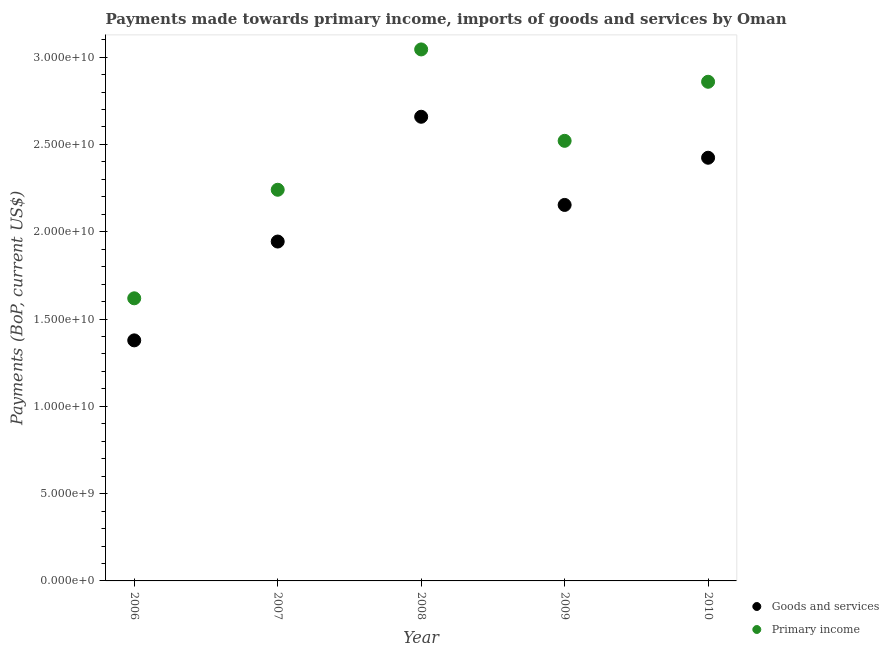Is the number of dotlines equal to the number of legend labels?
Provide a short and direct response. Yes. What is the payments made towards goods and services in 2006?
Keep it short and to the point. 1.38e+1. Across all years, what is the maximum payments made towards goods and services?
Make the answer very short. 2.66e+1. Across all years, what is the minimum payments made towards goods and services?
Your answer should be compact. 1.38e+1. What is the total payments made towards primary income in the graph?
Make the answer very short. 1.23e+11. What is the difference between the payments made towards goods and services in 2006 and that in 2009?
Ensure brevity in your answer.  -7.76e+09. What is the difference between the payments made towards primary income in 2010 and the payments made towards goods and services in 2006?
Your answer should be very brief. 1.48e+1. What is the average payments made towards primary income per year?
Your answer should be very brief. 2.46e+1. In the year 2006, what is the difference between the payments made towards primary income and payments made towards goods and services?
Your answer should be compact. 2.41e+09. In how many years, is the payments made towards goods and services greater than 19000000000 US$?
Your response must be concise. 4. What is the ratio of the payments made towards goods and services in 2008 to that in 2010?
Keep it short and to the point. 1.1. What is the difference between the highest and the second highest payments made towards goods and services?
Give a very brief answer. 2.35e+09. What is the difference between the highest and the lowest payments made towards goods and services?
Your response must be concise. 1.28e+1. In how many years, is the payments made towards primary income greater than the average payments made towards primary income taken over all years?
Offer a very short reply. 3. Does the payments made towards goods and services monotonically increase over the years?
Make the answer very short. No. How many dotlines are there?
Your answer should be compact. 2. How many years are there in the graph?
Offer a terse response. 5. Are the values on the major ticks of Y-axis written in scientific E-notation?
Ensure brevity in your answer.  Yes. Does the graph contain grids?
Make the answer very short. No. Where does the legend appear in the graph?
Give a very brief answer. Bottom right. How many legend labels are there?
Make the answer very short. 2. How are the legend labels stacked?
Provide a succinct answer. Vertical. What is the title of the graph?
Your response must be concise. Payments made towards primary income, imports of goods and services by Oman. Does "Net savings(excluding particulate emission damage)" appear as one of the legend labels in the graph?
Offer a very short reply. No. What is the label or title of the X-axis?
Offer a very short reply. Year. What is the label or title of the Y-axis?
Provide a succinct answer. Payments (BoP, current US$). What is the Payments (BoP, current US$) in Goods and services in 2006?
Your response must be concise. 1.38e+1. What is the Payments (BoP, current US$) in Primary income in 2006?
Make the answer very short. 1.62e+1. What is the Payments (BoP, current US$) of Goods and services in 2007?
Ensure brevity in your answer.  1.94e+1. What is the Payments (BoP, current US$) of Primary income in 2007?
Ensure brevity in your answer.  2.24e+1. What is the Payments (BoP, current US$) in Goods and services in 2008?
Keep it short and to the point. 2.66e+1. What is the Payments (BoP, current US$) of Primary income in 2008?
Provide a short and direct response. 3.04e+1. What is the Payments (BoP, current US$) in Goods and services in 2009?
Ensure brevity in your answer.  2.15e+1. What is the Payments (BoP, current US$) in Primary income in 2009?
Ensure brevity in your answer.  2.52e+1. What is the Payments (BoP, current US$) in Goods and services in 2010?
Offer a terse response. 2.42e+1. What is the Payments (BoP, current US$) of Primary income in 2010?
Provide a short and direct response. 2.86e+1. Across all years, what is the maximum Payments (BoP, current US$) of Goods and services?
Your answer should be compact. 2.66e+1. Across all years, what is the maximum Payments (BoP, current US$) of Primary income?
Provide a succinct answer. 3.04e+1. Across all years, what is the minimum Payments (BoP, current US$) of Goods and services?
Offer a very short reply. 1.38e+1. Across all years, what is the minimum Payments (BoP, current US$) of Primary income?
Keep it short and to the point. 1.62e+1. What is the total Payments (BoP, current US$) of Goods and services in the graph?
Offer a very short reply. 1.06e+11. What is the total Payments (BoP, current US$) in Primary income in the graph?
Offer a very short reply. 1.23e+11. What is the difference between the Payments (BoP, current US$) in Goods and services in 2006 and that in 2007?
Offer a very short reply. -5.66e+09. What is the difference between the Payments (BoP, current US$) of Primary income in 2006 and that in 2007?
Offer a very short reply. -6.22e+09. What is the difference between the Payments (BoP, current US$) in Goods and services in 2006 and that in 2008?
Your answer should be very brief. -1.28e+1. What is the difference between the Payments (BoP, current US$) in Primary income in 2006 and that in 2008?
Your answer should be compact. -1.43e+1. What is the difference between the Payments (BoP, current US$) of Goods and services in 2006 and that in 2009?
Your answer should be compact. -7.76e+09. What is the difference between the Payments (BoP, current US$) of Primary income in 2006 and that in 2009?
Your answer should be very brief. -9.02e+09. What is the difference between the Payments (BoP, current US$) in Goods and services in 2006 and that in 2010?
Provide a short and direct response. -1.05e+1. What is the difference between the Payments (BoP, current US$) in Primary income in 2006 and that in 2010?
Make the answer very short. -1.24e+1. What is the difference between the Payments (BoP, current US$) in Goods and services in 2007 and that in 2008?
Keep it short and to the point. -7.15e+09. What is the difference between the Payments (BoP, current US$) in Primary income in 2007 and that in 2008?
Your answer should be compact. -8.04e+09. What is the difference between the Payments (BoP, current US$) of Goods and services in 2007 and that in 2009?
Give a very brief answer. -2.10e+09. What is the difference between the Payments (BoP, current US$) of Primary income in 2007 and that in 2009?
Ensure brevity in your answer.  -2.80e+09. What is the difference between the Payments (BoP, current US$) of Goods and services in 2007 and that in 2010?
Offer a terse response. -4.80e+09. What is the difference between the Payments (BoP, current US$) of Primary income in 2007 and that in 2010?
Make the answer very short. -6.19e+09. What is the difference between the Payments (BoP, current US$) of Goods and services in 2008 and that in 2009?
Offer a very short reply. 5.05e+09. What is the difference between the Payments (BoP, current US$) in Primary income in 2008 and that in 2009?
Your answer should be very brief. 5.24e+09. What is the difference between the Payments (BoP, current US$) in Goods and services in 2008 and that in 2010?
Offer a very short reply. 2.35e+09. What is the difference between the Payments (BoP, current US$) of Primary income in 2008 and that in 2010?
Offer a terse response. 1.85e+09. What is the difference between the Payments (BoP, current US$) of Goods and services in 2009 and that in 2010?
Give a very brief answer. -2.70e+09. What is the difference between the Payments (BoP, current US$) in Primary income in 2009 and that in 2010?
Provide a short and direct response. -3.38e+09. What is the difference between the Payments (BoP, current US$) of Goods and services in 2006 and the Payments (BoP, current US$) of Primary income in 2007?
Give a very brief answer. -8.63e+09. What is the difference between the Payments (BoP, current US$) of Goods and services in 2006 and the Payments (BoP, current US$) of Primary income in 2008?
Your answer should be very brief. -1.67e+1. What is the difference between the Payments (BoP, current US$) of Goods and services in 2006 and the Payments (BoP, current US$) of Primary income in 2009?
Ensure brevity in your answer.  -1.14e+1. What is the difference between the Payments (BoP, current US$) in Goods and services in 2006 and the Payments (BoP, current US$) in Primary income in 2010?
Your answer should be very brief. -1.48e+1. What is the difference between the Payments (BoP, current US$) in Goods and services in 2007 and the Payments (BoP, current US$) in Primary income in 2008?
Keep it short and to the point. -1.10e+1. What is the difference between the Payments (BoP, current US$) of Goods and services in 2007 and the Payments (BoP, current US$) of Primary income in 2009?
Offer a very short reply. -5.77e+09. What is the difference between the Payments (BoP, current US$) of Goods and services in 2007 and the Payments (BoP, current US$) of Primary income in 2010?
Offer a very short reply. -9.15e+09. What is the difference between the Payments (BoP, current US$) of Goods and services in 2008 and the Payments (BoP, current US$) of Primary income in 2009?
Give a very brief answer. 1.38e+09. What is the difference between the Payments (BoP, current US$) of Goods and services in 2008 and the Payments (BoP, current US$) of Primary income in 2010?
Offer a very short reply. -2.00e+09. What is the difference between the Payments (BoP, current US$) in Goods and services in 2009 and the Payments (BoP, current US$) in Primary income in 2010?
Your answer should be very brief. -7.05e+09. What is the average Payments (BoP, current US$) of Goods and services per year?
Your answer should be compact. 2.11e+1. What is the average Payments (BoP, current US$) of Primary income per year?
Your answer should be compact. 2.46e+1. In the year 2006, what is the difference between the Payments (BoP, current US$) in Goods and services and Payments (BoP, current US$) in Primary income?
Offer a very short reply. -2.41e+09. In the year 2007, what is the difference between the Payments (BoP, current US$) in Goods and services and Payments (BoP, current US$) in Primary income?
Your answer should be very brief. -2.97e+09. In the year 2008, what is the difference between the Payments (BoP, current US$) of Goods and services and Payments (BoP, current US$) of Primary income?
Make the answer very short. -3.86e+09. In the year 2009, what is the difference between the Payments (BoP, current US$) of Goods and services and Payments (BoP, current US$) of Primary income?
Offer a very short reply. -3.67e+09. In the year 2010, what is the difference between the Payments (BoP, current US$) of Goods and services and Payments (BoP, current US$) of Primary income?
Offer a terse response. -4.35e+09. What is the ratio of the Payments (BoP, current US$) of Goods and services in 2006 to that in 2007?
Keep it short and to the point. 0.71. What is the ratio of the Payments (BoP, current US$) of Primary income in 2006 to that in 2007?
Your response must be concise. 0.72. What is the ratio of the Payments (BoP, current US$) of Goods and services in 2006 to that in 2008?
Your response must be concise. 0.52. What is the ratio of the Payments (BoP, current US$) of Primary income in 2006 to that in 2008?
Offer a very short reply. 0.53. What is the ratio of the Payments (BoP, current US$) in Goods and services in 2006 to that in 2009?
Ensure brevity in your answer.  0.64. What is the ratio of the Payments (BoP, current US$) of Primary income in 2006 to that in 2009?
Your answer should be very brief. 0.64. What is the ratio of the Payments (BoP, current US$) of Goods and services in 2006 to that in 2010?
Your answer should be compact. 0.57. What is the ratio of the Payments (BoP, current US$) of Primary income in 2006 to that in 2010?
Offer a terse response. 0.57. What is the ratio of the Payments (BoP, current US$) of Goods and services in 2007 to that in 2008?
Your answer should be compact. 0.73. What is the ratio of the Payments (BoP, current US$) of Primary income in 2007 to that in 2008?
Keep it short and to the point. 0.74. What is the ratio of the Payments (BoP, current US$) in Goods and services in 2007 to that in 2009?
Your answer should be compact. 0.9. What is the ratio of the Payments (BoP, current US$) of Primary income in 2007 to that in 2009?
Make the answer very short. 0.89. What is the ratio of the Payments (BoP, current US$) of Goods and services in 2007 to that in 2010?
Keep it short and to the point. 0.8. What is the ratio of the Payments (BoP, current US$) in Primary income in 2007 to that in 2010?
Offer a terse response. 0.78. What is the ratio of the Payments (BoP, current US$) of Goods and services in 2008 to that in 2009?
Provide a short and direct response. 1.23. What is the ratio of the Payments (BoP, current US$) of Primary income in 2008 to that in 2009?
Ensure brevity in your answer.  1.21. What is the ratio of the Payments (BoP, current US$) in Goods and services in 2008 to that in 2010?
Provide a succinct answer. 1.1. What is the ratio of the Payments (BoP, current US$) of Primary income in 2008 to that in 2010?
Offer a very short reply. 1.06. What is the ratio of the Payments (BoP, current US$) of Goods and services in 2009 to that in 2010?
Ensure brevity in your answer.  0.89. What is the ratio of the Payments (BoP, current US$) in Primary income in 2009 to that in 2010?
Your answer should be compact. 0.88. What is the difference between the highest and the second highest Payments (BoP, current US$) in Goods and services?
Your answer should be very brief. 2.35e+09. What is the difference between the highest and the second highest Payments (BoP, current US$) in Primary income?
Your response must be concise. 1.85e+09. What is the difference between the highest and the lowest Payments (BoP, current US$) of Goods and services?
Your answer should be very brief. 1.28e+1. What is the difference between the highest and the lowest Payments (BoP, current US$) in Primary income?
Give a very brief answer. 1.43e+1. 